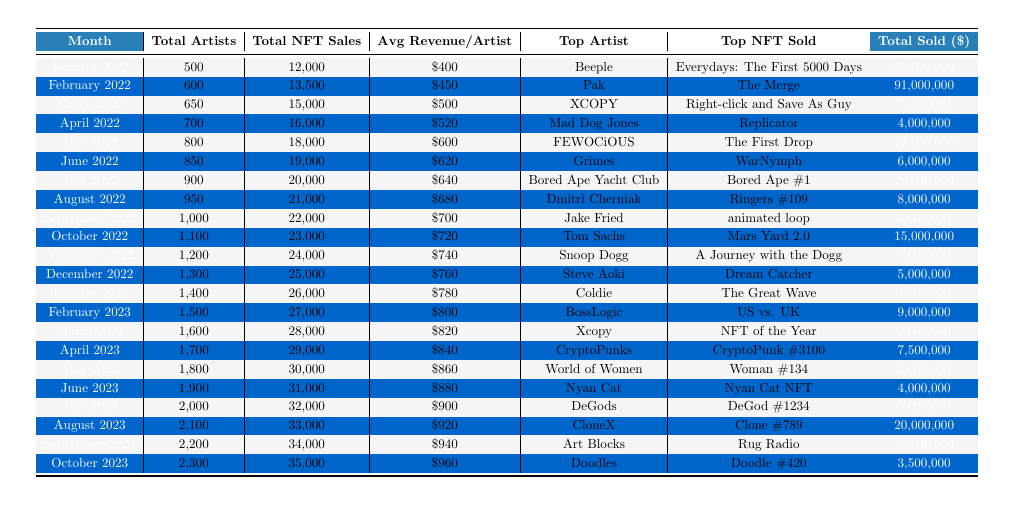What was the total number of NFT sales in July 2022? In July 2022, the table shows a total of 20,000 NFT sales.
Answer: 20,000 Who was the top artist in March 2023? The table indicates that Xcopy was the top artist in March 2023.
Answer: Xcopy What is the average revenue per artist for February 2022? The table states that the average revenue per artist for February 2022 is $450.
Answer: $450 Did the number of total artists increase from January 2022 to October 2023? Yes, the table shows a rise in total artists from 500 in January 2022 to 2,300 in October 2023.
Answer: Yes What is the difference in total NFT sales between May 2022 and June 2022? The total sales in May 2022 were 18,000, and in June 2022 were 19,000. The difference is 19,000 - 18,000 = 1,000.
Answer: 1,000 What was the trend in average revenue per artist from January 2022 to October 2023? Analyzing the average revenue per artist, it increased consistently from $400 in January 2022 to $960 in October 2023, indicating a positive trend overall.
Answer: Positive trend What was the total sold amount for February 2023 compared to March 2023? February 2023 had $9,000,000 sold and March 2023 had $2,000,000. The total sold amount declined from February to March by $9,000,000 - $2,000,000 = $7,000,000.
Answer: Declined by $7,000,000 In which month did the average revenue per artist first exceed $800? The average revenue per artist first exceeded $800 in February 2023, where it reached $800.
Answer: February 2023 What monthly increase in total NFT sales occurred from October 2022 to November 2022? In October 2022, there were 23,000 total NFT sales, and in November 2022 there were 24,000, resulting in an increase of 24,000 - 23,000 = 1,000 sales.
Answer: 1,000 Was the highest total sold value for any NFT greater than $100 million in the provided data? No, the highest total sold value was $91,000,000 in February 2022, which is less than $100 million.
Answer: No How many artists were engaged in July 2023, and how does this compare to July 2022? In July 2023, there were 2,000 artists engaged, an increase from July 2022, which had 900 artists.
Answer: Increased by 1,100 artists 